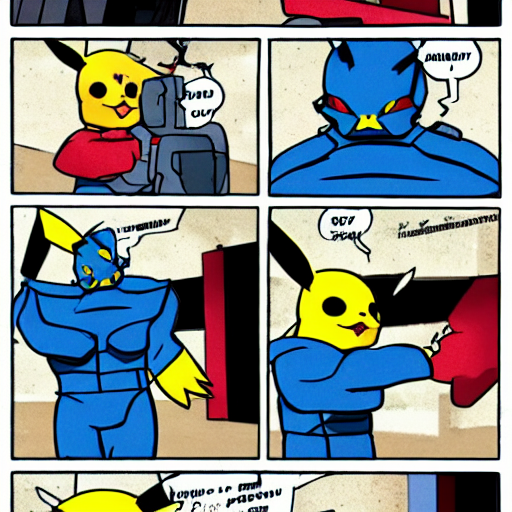What might be happening in this sequence? In the sequence, it appears that two characters are involved in a typical hero-villain encounter which is a staple in superhero narratives. The first frame shows a character resembling a Pikachu in a superhero costume, seemingly preparing for or reacting to an unseen event. The next few frames reveal the entrance of another character, likely an antagonist, followed by a confrontation suggested by the final frame with an illustrative 'oomph' sound effect, indicating a physical interaction. What elements indicate that this image might be part of a larger story? Multiple elements hint at a larger narrative context. The use of sequential panels suggests this is part of a comic strip or book, where each panel contributes to a broader story. The speech bubbles with unfinished sentences indicate ongoing dialogue, the character costumes suggest specific roles and identities, and the depicted action sequences imply a conflict that is part of a larger plot. Additionally, the art style and presentation signal that this is one fragment of a serialized medium commonly used to tell complex and multi-part stories. 